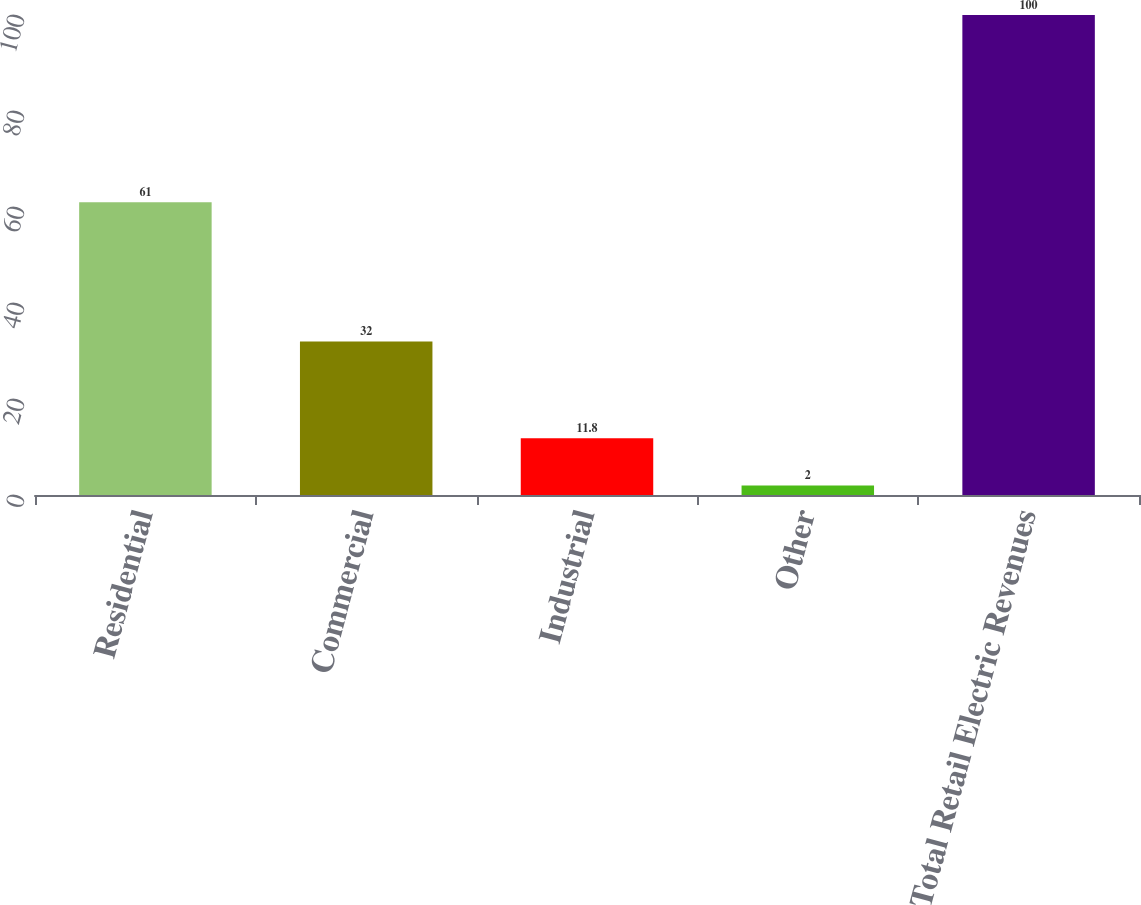<chart> <loc_0><loc_0><loc_500><loc_500><bar_chart><fcel>Residential<fcel>Commercial<fcel>Industrial<fcel>Other<fcel>Total Retail Electric Revenues<nl><fcel>61<fcel>32<fcel>11.8<fcel>2<fcel>100<nl></chart> 